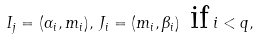Convert formula to latex. <formula><loc_0><loc_0><loc_500><loc_500>I _ { j } = ( \alpha _ { i } , m _ { i } ) , \, J _ { i } = ( m _ { i } , \beta _ { i } ) \ \text {if} \, i < { q } ,</formula> 